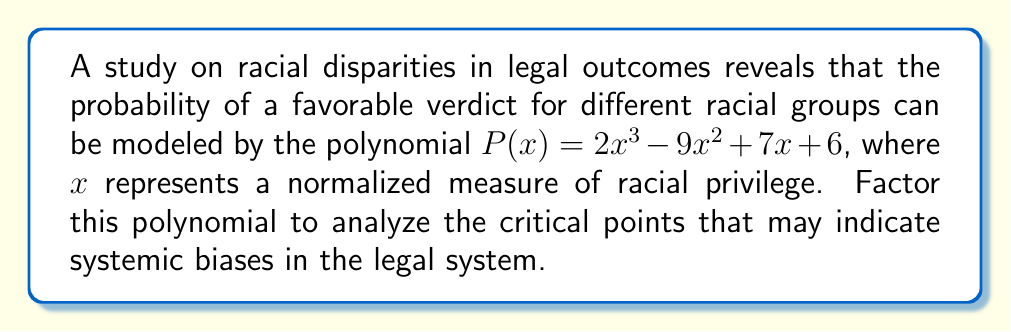Can you answer this question? To factor the polynomial $P(x) = 2x^3 - 9x^2 + 7x + 6$, we'll follow these steps:

1) First, let's check if there's a common factor:
   There is no common factor for all terms.

2) Next, we'll use the rational root theorem to find potential roots:
   Factors of the constant term (6): ±1, ±2, ±3, ±6
   Factors of the leading coefficient (2): ±1, ±2

   Potential rational roots: ±1, ±2, ±3, ±6, ±1/2, ±3/2

3) Test these values in the polynomial:
   $P(1) = 2(1)^3 - 9(1)^2 + 7(1) + 6 = 2 - 9 + 7 + 6 = 6$
   $P(-1) = 2(-1)^3 - 9(-1)^2 + 7(-1) + 6 = -2 - 9 - 7 + 6 = -12$
   $P(2) = 2(2)^3 - 9(2)^2 + 7(2) + 6 = 16 - 36 + 14 + 6 = 0$

   We found a root: $x = 2$

4) Divide the polynomial by $(x - 2)$:
   $2x^3 - 9x^2 + 7x + 6 = (x - 2)(2x^2 - 5x - 3)$

5) Now factor the quadratic $2x^2 - 5x - 3$:
   Using the quadratic formula, we find the roots are $3$ and $-1/2$

6) Therefore, the fully factored polynomial is:
   $P(x) = (x - 2)(x - 3)(2x + 1)$

This factorization reveals the critical points in the model of racial disparities in legal outcomes, which could be interpreted as thresholds of racial privilege where the probability of favorable verdicts changes significantly.
Answer: $P(x) = (x - 2)(x - 3)(2x + 1)$ 